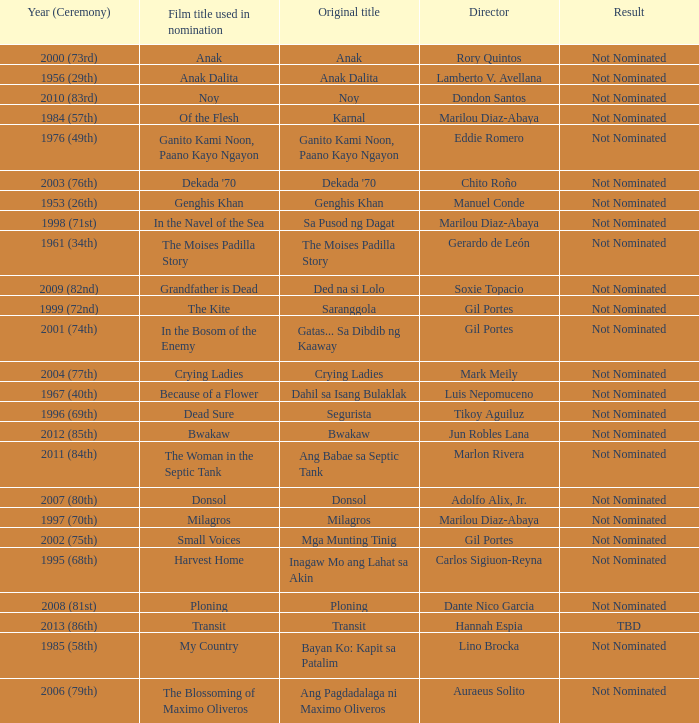What is the year when not nominated was the result, and In the Navel of the Sea was the film title used in nomination? 1998 (71st). 